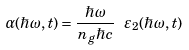Convert formula to latex. <formula><loc_0><loc_0><loc_500><loc_500>\alpha ( \hbar { \omega } , t ) = \frac { \hbar { \omega } } { n _ { g } \hbar { c } } \ \varepsilon _ { 2 } ( \hbar { \omega } , t )</formula> 